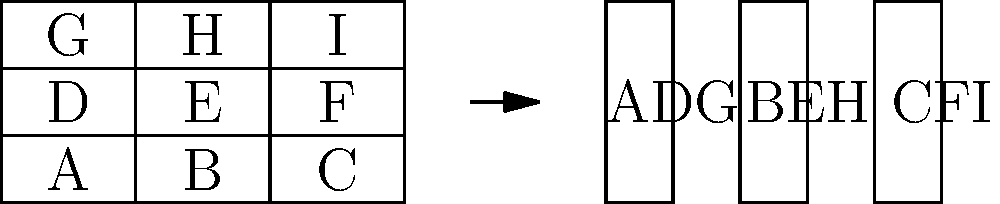In a shipping yard, nine containers (A through I) are currently arranged in a 3x3 grid. To optimize space and improve accessibility, you need to restack these containers into three vertical stacks. What is the most efficient way to rearrange the containers to minimize the number of moves required? To solve this problem, we need to analyze the current arrangement and determine the most efficient restacking method. Let's approach this step-by-step:

1. Current arrangement:
   - Top row: G, H, I
   - Middle row: D, E, F
   - Bottom row: A, B, C

2. Desired arrangement:
   Three vertical stacks, each containing three containers.

3. Optimal stacking strategy:
   To minimize moves, we should create stacks that require the least amount of container displacement.

4. Analyzing the columns:
   - Left column: A, D, G
   - Middle column: B, E, H
   - Right column: C, F, I

5. Optimal solution:
   By keeping the containers in their current columns and simply adjusting their vertical positions, we can achieve the desired arrangement with the fewest moves.

6. Resulting stacks:
   - Stack 1: A (bottom), D (middle), G (top)
   - Stack 2: B (bottom), E (middle), H (top)
   - Stack 3: C (bottom), F (middle), I (top)

7. Number of moves required:
   - G, H, and I each move down two positions: 3 * 2 = 6 moves
   - D, E, and F each move down one position: 3 * 1 = 3 moves
   - A, B, and C remain in place: 0 moves
   Total moves: 6 + 3 + 0 = 9 moves

This solution requires only 9 moves, which is the minimum possible number of moves to achieve the desired arrangement.
Answer: ADG, BEH, CFI 